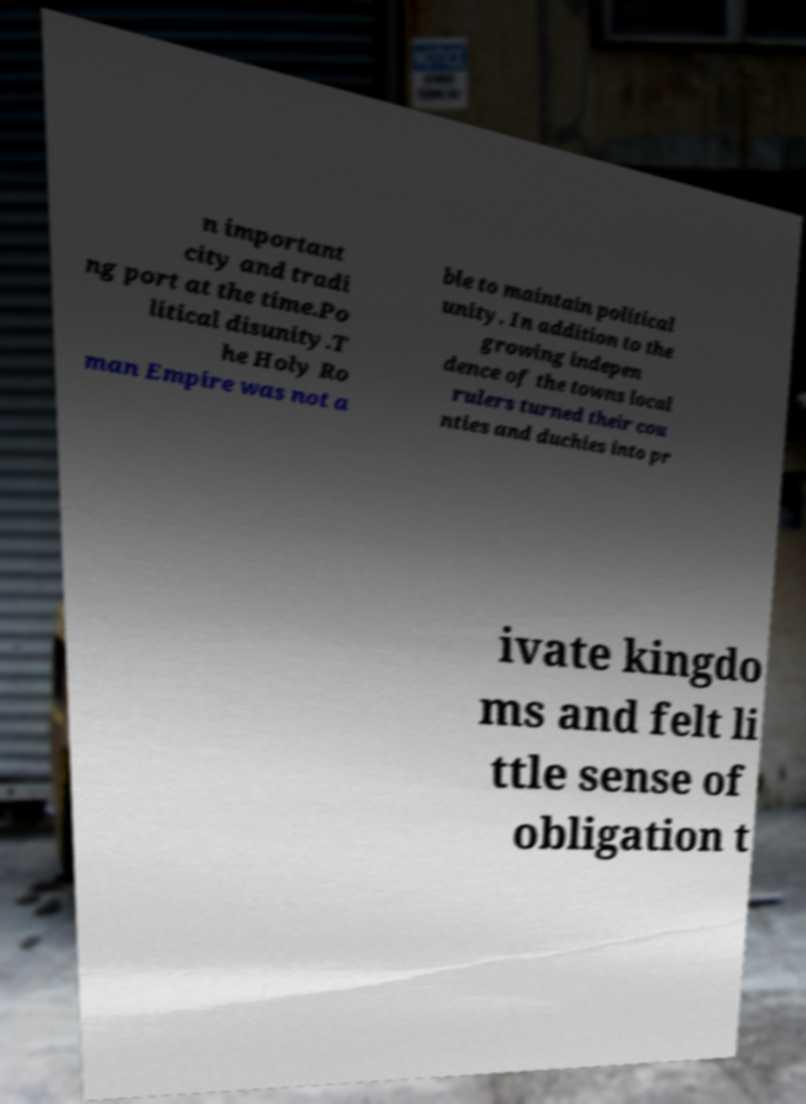Please read and relay the text visible in this image. What does it say? n important city and tradi ng port at the time.Po litical disunity.T he Holy Ro man Empire was not a ble to maintain political unity. In addition to the growing indepen dence of the towns local rulers turned their cou nties and duchies into pr ivate kingdo ms and felt li ttle sense of obligation t 